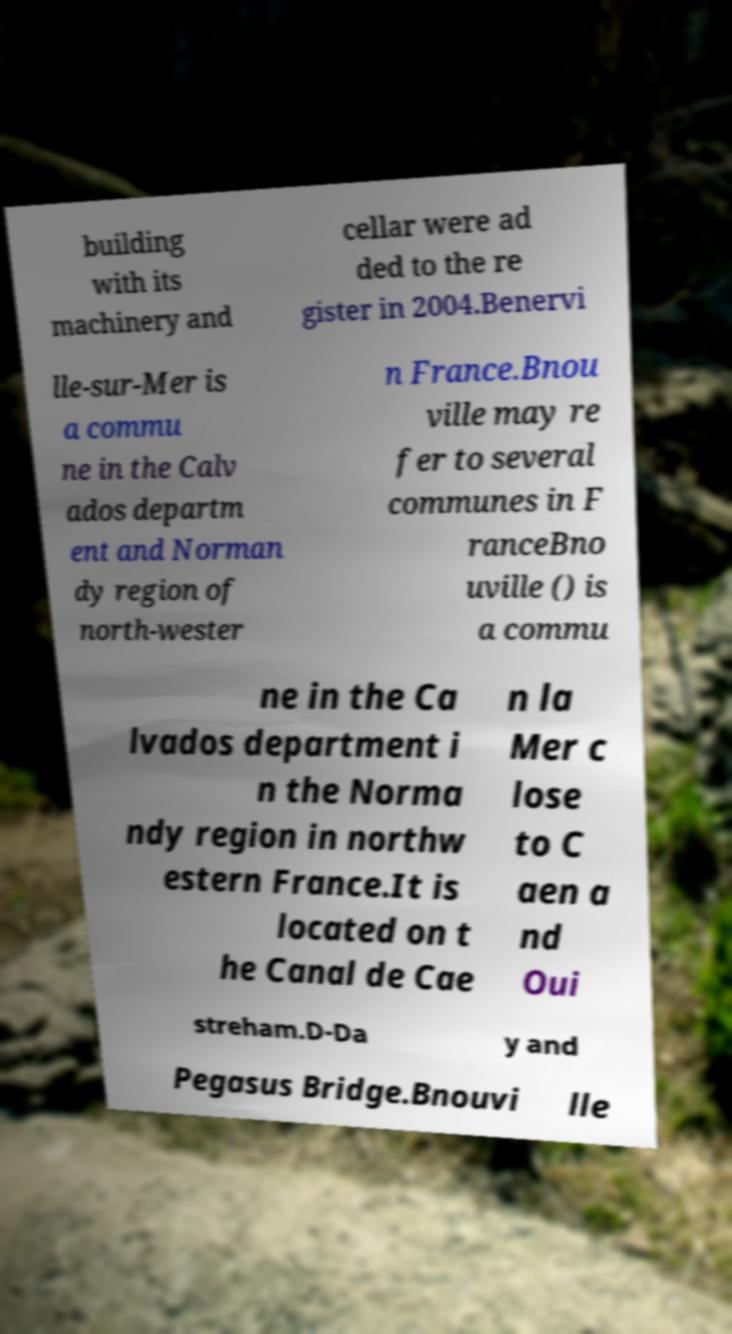Can you accurately transcribe the text from the provided image for me? building with its machinery and cellar were ad ded to the re gister in 2004.Benervi lle-sur-Mer is a commu ne in the Calv ados departm ent and Norman dy region of north-wester n France.Bnou ville may re fer to several communes in F ranceBno uville () is a commu ne in the Ca lvados department i n the Norma ndy region in northw estern France.It is located on t he Canal de Cae n la Mer c lose to C aen a nd Oui streham.D-Da y and Pegasus Bridge.Bnouvi lle 